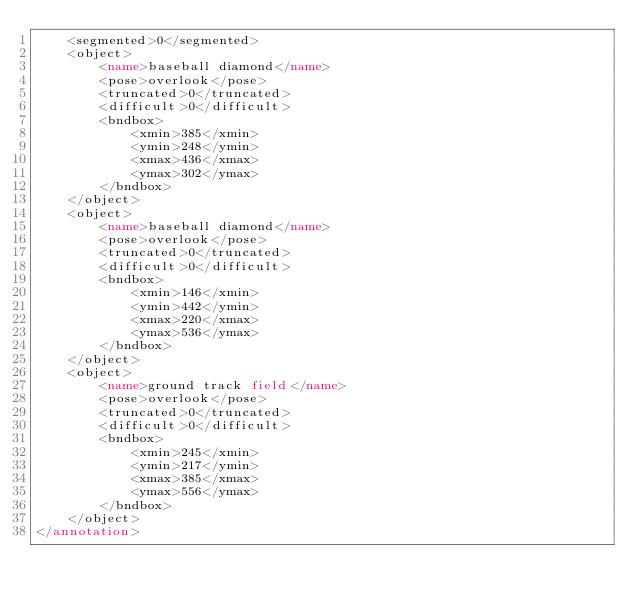Convert code to text. <code><loc_0><loc_0><loc_500><loc_500><_XML_>	<segmented>0</segmented>
	<object>
		<name>baseball diamond</name>
		<pose>overlook</pose>
		<truncated>0</truncated>
		<difficult>0</difficult>
		<bndbox>
			<xmin>385</xmin>
			<ymin>248</ymin>
			<xmax>436</xmax>
			<ymax>302</ymax>
		</bndbox>
	</object>
	<object>
		<name>baseball diamond</name>
		<pose>overlook</pose>
		<truncated>0</truncated>
		<difficult>0</difficult>
		<bndbox>
			<xmin>146</xmin>
			<ymin>442</ymin>
			<xmax>220</xmax>
			<ymax>536</ymax>
		</bndbox>
	</object>
	<object>
		<name>ground track field</name>
		<pose>overlook</pose>
		<truncated>0</truncated>
		<difficult>0</difficult>
		<bndbox>
			<xmin>245</xmin>
			<ymin>217</ymin>
			<xmax>385</xmax>
			<ymax>556</ymax>
		</bndbox>
	</object>
</annotation>
</code> 